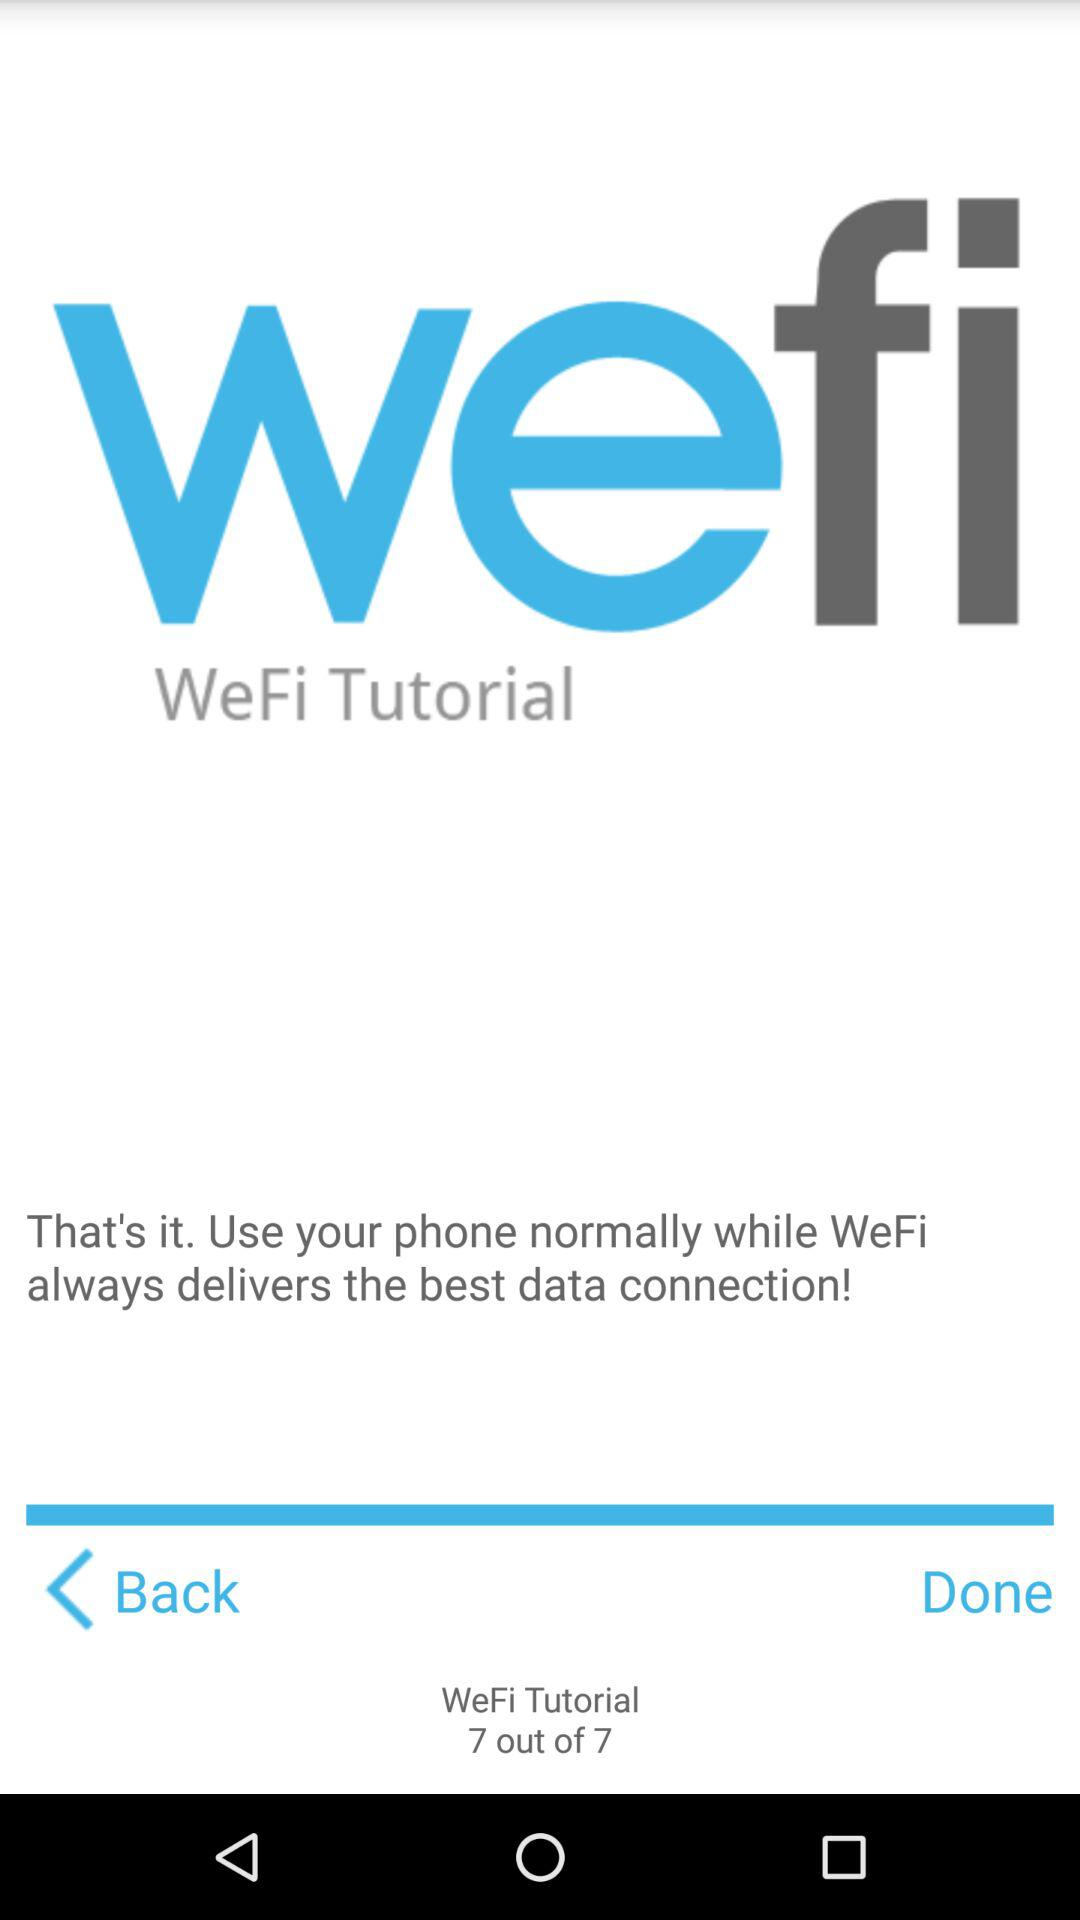What is the application name? The application name is "wefi". 